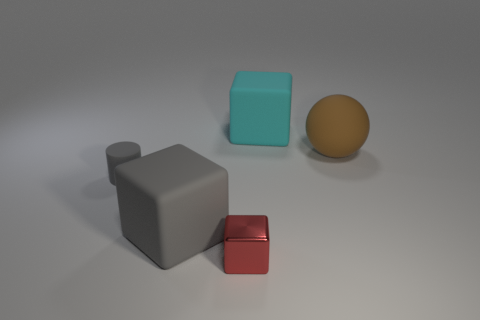What number of large things are cylinders or spheres?
Provide a short and direct response. 1. What color is the matte object that is both behind the big gray rubber thing and in front of the big sphere?
Your answer should be very brief. Gray. Is there another cyan rubber thing of the same shape as the big cyan thing?
Keep it short and to the point. No. What is the material of the cyan object?
Offer a terse response. Rubber. There is a cyan matte block; are there any gray cylinders on the left side of it?
Give a very brief answer. Yes. Is the shape of the red metallic object the same as the brown object?
Offer a very short reply. No. How many other objects are the same size as the gray matte cylinder?
Provide a succinct answer. 1. What number of objects are either big cubes to the left of the tiny cube or rubber objects?
Your response must be concise. 4. The rubber sphere is what color?
Your response must be concise. Brown. What material is the big object that is behind the big brown matte thing?
Ensure brevity in your answer.  Rubber. 